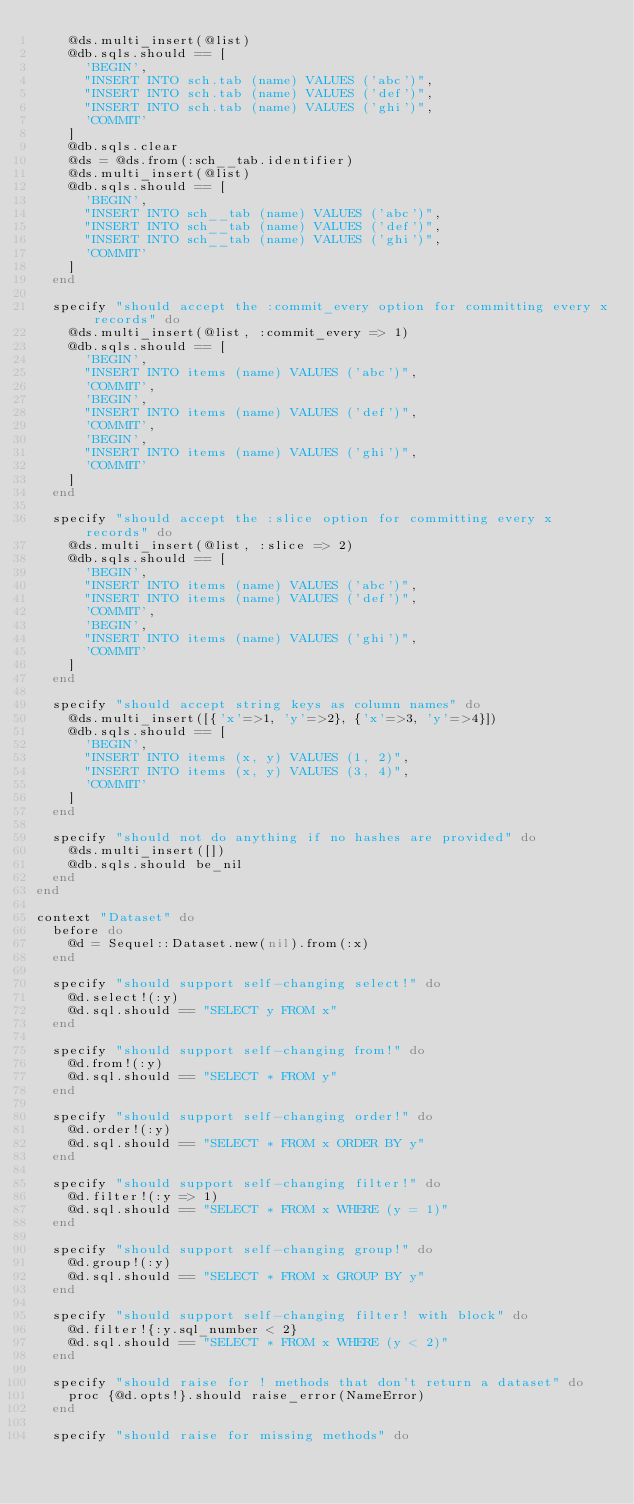<code> <loc_0><loc_0><loc_500><loc_500><_Ruby_>    @ds.multi_insert(@list)
    @db.sqls.should == [
      'BEGIN',
      "INSERT INTO sch.tab (name) VALUES ('abc')",
      "INSERT INTO sch.tab (name) VALUES ('def')",
      "INSERT INTO sch.tab (name) VALUES ('ghi')",
      'COMMIT'
    ]
    @db.sqls.clear
    @ds = @ds.from(:sch__tab.identifier)
    @ds.multi_insert(@list)
    @db.sqls.should == [
      'BEGIN',
      "INSERT INTO sch__tab (name) VALUES ('abc')",
      "INSERT INTO sch__tab (name) VALUES ('def')",
      "INSERT INTO sch__tab (name) VALUES ('ghi')",
      'COMMIT'
    ]
  end
  
  specify "should accept the :commit_every option for committing every x records" do
    @ds.multi_insert(@list, :commit_every => 1)
    @db.sqls.should == [
      'BEGIN',
      "INSERT INTO items (name) VALUES ('abc')",
      'COMMIT',
      'BEGIN',
      "INSERT INTO items (name) VALUES ('def')",
      'COMMIT',
      'BEGIN',
      "INSERT INTO items (name) VALUES ('ghi')",
      'COMMIT'
    ]
  end

  specify "should accept the :slice option for committing every x records" do
    @ds.multi_insert(@list, :slice => 2)
    @db.sqls.should == [
      'BEGIN',
      "INSERT INTO items (name) VALUES ('abc')",
      "INSERT INTO items (name) VALUES ('def')",
      'COMMIT',
      'BEGIN',
      "INSERT INTO items (name) VALUES ('ghi')",
      'COMMIT'
    ]
  end
  
  specify "should accept string keys as column names" do
    @ds.multi_insert([{'x'=>1, 'y'=>2}, {'x'=>3, 'y'=>4}])
    @db.sqls.should == [
      'BEGIN',
      "INSERT INTO items (x, y) VALUES (1, 2)",
      "INSERT INTO items (x, y) VALUES (3, 4)",
      'COMMIT'
    ]
  end

  specify "should not do anything if no hashes are provided" do
    @ds.multi_insert([])
    @db.sqls.should be_nil
  end
end

context "Dataset" do
  before do
    @d = Sequel::Dataset.new(nil).from(:x)
  end

  specify "should support self-changing select!" do
    @d.select!(:y)
    @d.sql.should == "SELECT y FROM x"
  end
  
  specify "should support self-changing from!" do
    @d.from!(:y)
    @d.sql.should == "SELECT * FROM y"
  end

  specify "should support self-changing order!" do
    @d.order!(:y)
    @d.sql.should == "SELECT * FROM x ORDER BY y"
  end
  
  specify "should support self-changing filter!" do
    @d.filter!(:y => 1)
    @d.sql.should == "SELECT * FROM x WHERE (y = 1)"
  end

  specify "should support self-changing group!" do
    @d.group!(:y)
    @d.sql.should == "SELECT * FROM x GROUP BY y"
  end

  specify "should support self-changing filter! with block" do
    @d.filter!{:y.sql_number < 2}
    @d.sql.should == "SELECT * FROM x WHERE (y < 2)"
  end
  
  specify "should raise for ! methods that don't return a dataset" do
    proc {@d.opts!}.should raise_error(NameError)
  end
  
  specify "should raise for missing methods" do</code> 